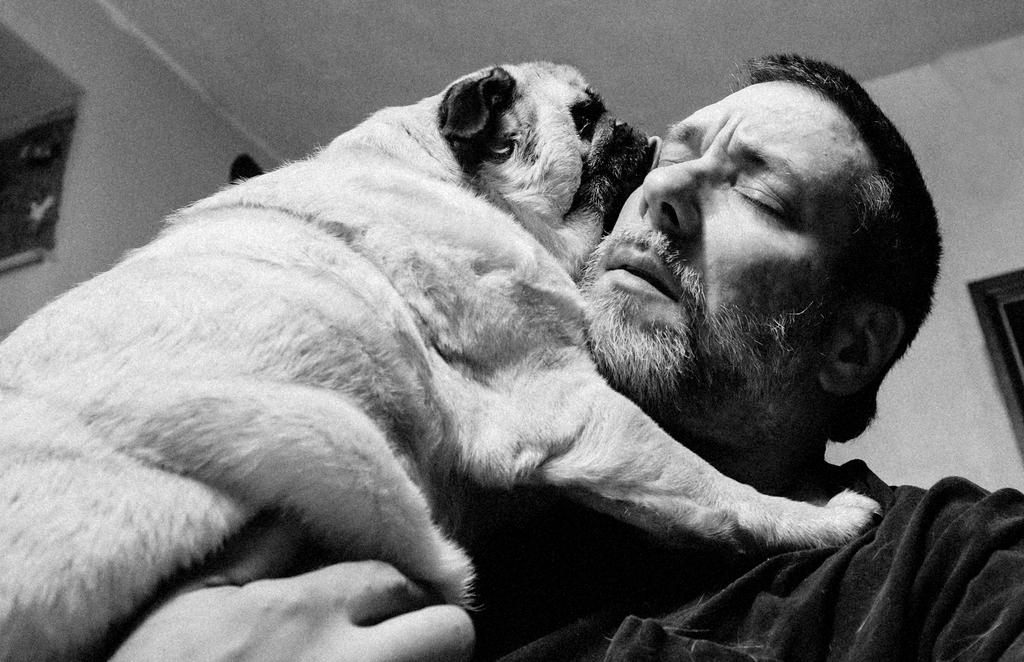What is the person in the image holding? The person in the image is holding a dog. What can be seen in the background of the image? There is a roof and a wall in the background of the image. How many lizards can be seen on the roof in the image? There are no lizards visible on the roof in the image. What type of station is the person in the image traveling to or from? There is no indication of a station or any travel-related context in the image. 